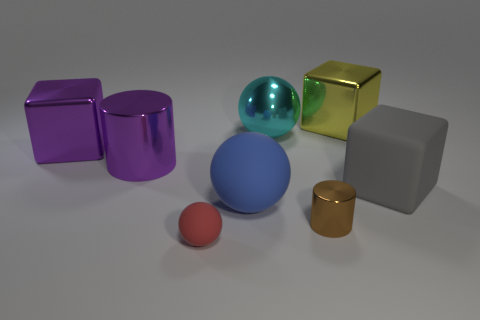Do the brown thing and the large cyan sphere have the same material? Based on the image, it's not possible to determine with certainty if the brown object and the large cyan sphere have the same material just by color alone, as the same material can have different colors. However, they both exhibit a smooth and shiny appearance, which suggests that they might have similar reflective properties, commonly found in materials such as plastic or polished metal. 